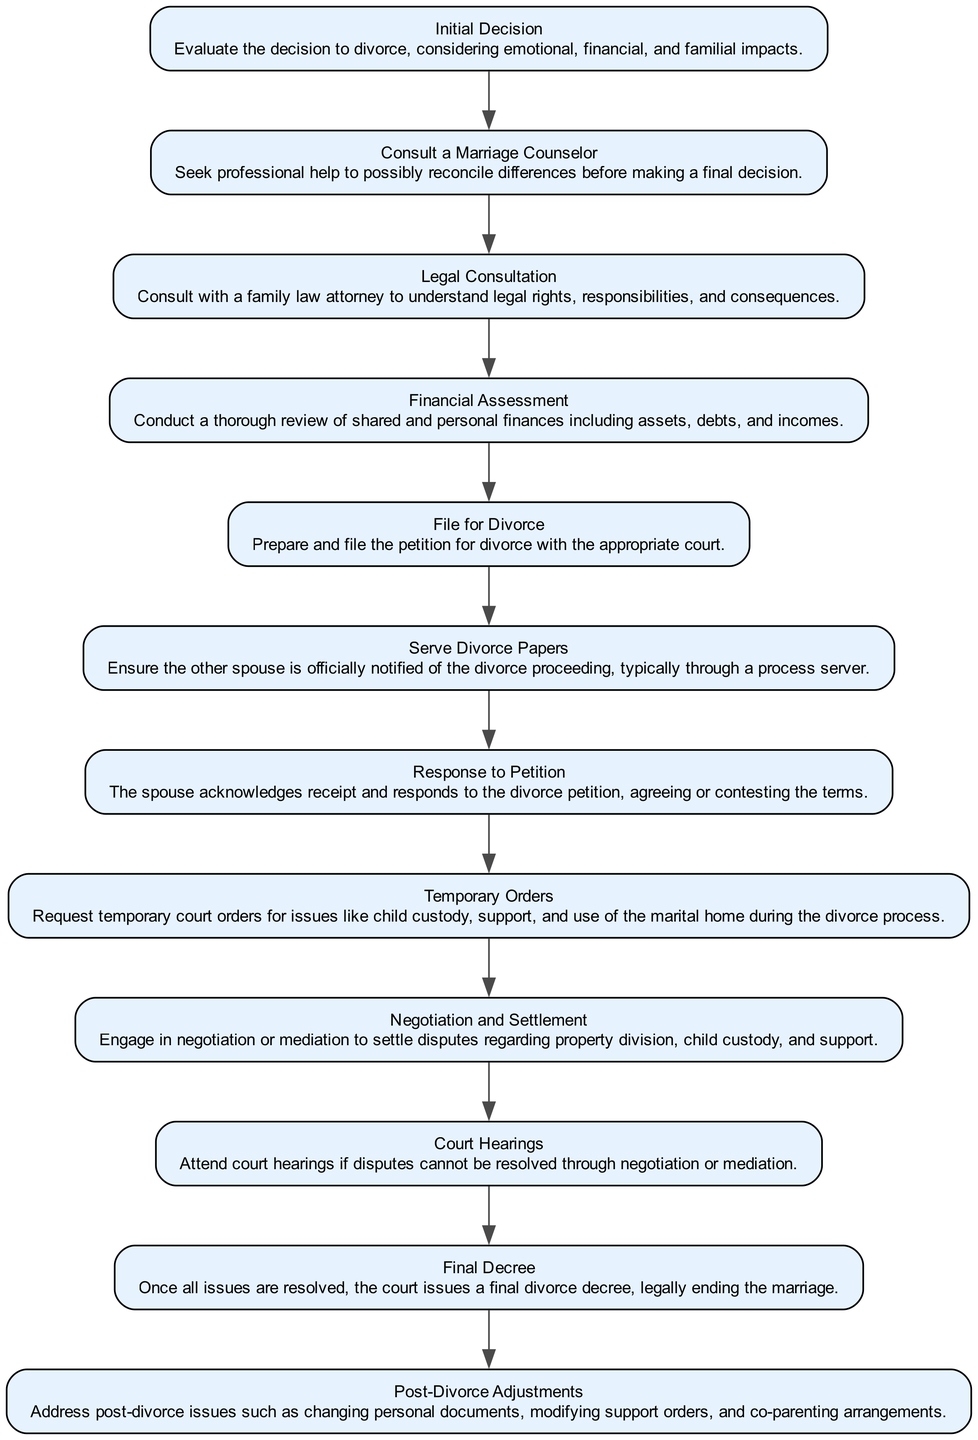What is the first step in the divorce process? The diagram starts with the "Initial Decision" node, which indicates that evaluating the decision to divorce is foundational before proceeding.
Answer: Initial Decision What follows the "Consult a Marriage Counselor" step? The flow chart shows that from "Consult a Marriage Counselor," the next step is "Legal Consultation," indicating the sequential order of these processes.
Answer: Legal Consultation How many total steps are there in the divorce process? By counting the nodes listed in the flowchart, there are a total of twelve elements starting from the initial decision to the final decree.
Answer: Twelve What is the purpose of the "Temporary Orders" step? The diagram describes "Temporary Orders" as a request for court orders regarding issues like custody and support during the divorce, highlighting its function in the sequence.
Answer: Request temporary court orders What do you proceed to after the "Serve Divorce Papers" step? After "Serve Divorce Papers," the next step indicated in the diagram is "Response to Petition," which shows the required acknowledgment from the other spouse.
Answer: Response to Petition What step directly precedes the "Final Decree" step? The diagram shows that "Court Hearings" is the step directly before "Final Decree," indicating that resolution of disputes may occur in court before finalization.
Answer: Court Hearings Which step addresses issues related to child custody and support? In the flowchart, "Temporary Orders" specifically mentions addressing issues such as child custody and support, indicating its importance in securing arrangements before the final decree.
Answer: Temporary Orders In what situation would a "Court Hearing" be necessary? The diagram suggests that "Court Hearings" are necessary only when disputes cannot be resolved through negotiation or mediation, highlighting the significance of alternate dispute resolution methods beforehand.
Answer: When disputes cannot be resolved 